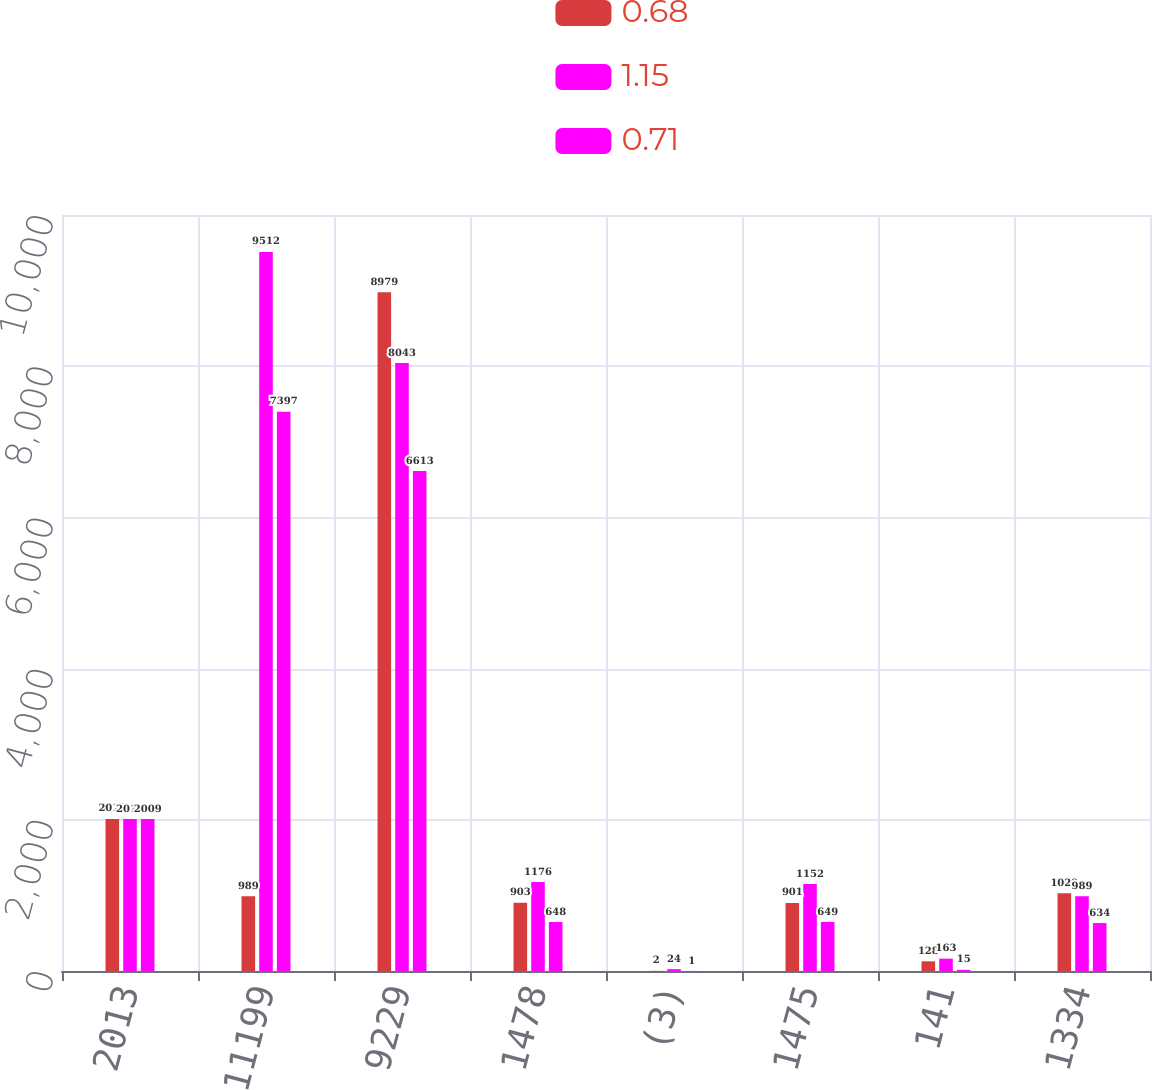Convert chart. <chart><loc_0><loc_0><loc_500><loc_500><stacked_bar_chart><ecel><fcel>2013<fcel>11199<fcel>9229<fcel>1478<fcel>(3)<fcel>1475<fcel>141<fcel>1334<nl><fcel>0.68<fcel>2012<fcel>989<fcel>8979<fcel>903<fcel>2<fcel>901<fcel>128<fcel>1029<nl><fcel>1.15<fcel>2010<fcel>9512<fcel>8043<fcel>1176<fcel>24<fcel>1152<fcel>163<fcel>989<nl><fcel>0.71<fcel>2009<fcel>7397<fcel>6613<fcel>648<fcel>1<fcel>649<fcel>15<fcel>634<nl></chart> 